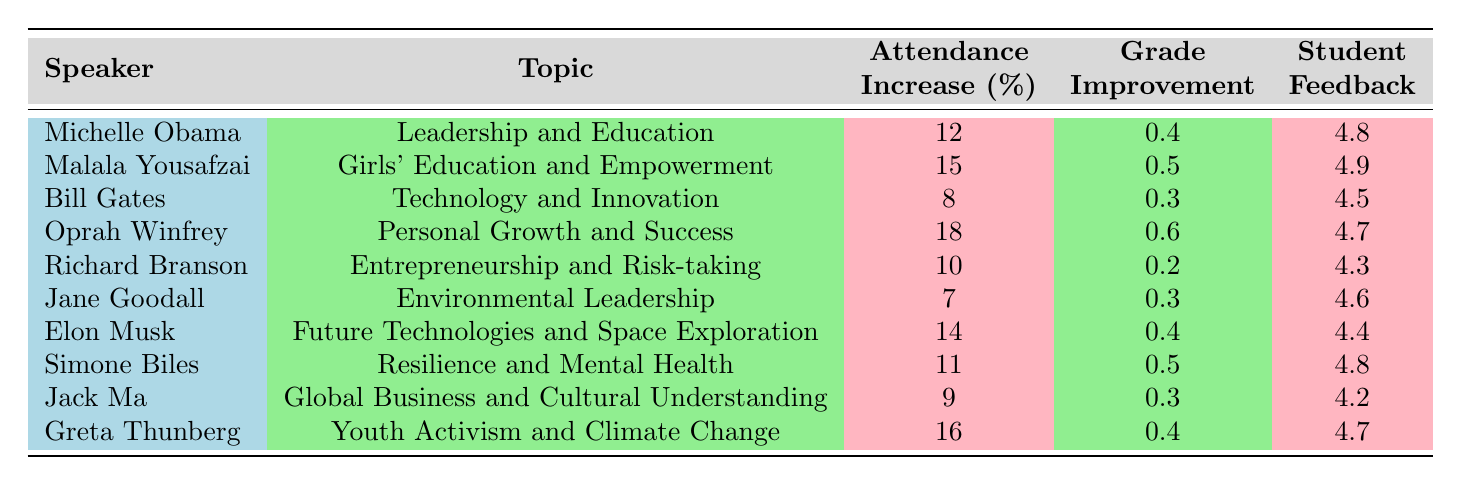What speaker achieved the highest attendance increase? By looking at the "Attendance Increase" column, Oprah Winfrey has the highest value of 18%.
Answer: Oprah Winfrey What is the attendance increase for Malala Yousafzai? The table shows that Malala Yousafzai has an attendance increase of 15%.
Answer: 15% Which speaker has the lowest grade improvement? The "Grade Improvement" column indicates that Richard Branson has the lowest value of 0.2.
Answer: Richard Branson What is the average student feedback score for all speakers? To find the average, we sum all feedback scores (4.8 + 4.9 + 4.5 + 4.7 + 4.3 + 4.6 + 4.4 + 4.8 + 4.2 + 4.7 = 46) and divide by the number of speakers (10). Average = 46 / 10 = 4.6.
Answer: 4.6 Did any speaker have an attendance increase of 12% or less? By checking the "Attendance Increase" column, only Bill Gates (8%) and Jane Goodall (7%) meet this condition.
Answer: Yes Which speaker had the highest grade improvement along with attendance increase? Oprah Winfrey has the highest attendance increase of 18% and a grade improvement of 0.6, which is also the highest.
Answer: Oprah Winfrey How many speakers had an attendance increase greater than or equal to 15%? By reviewing the "Attendance Increase" column, the speakers with increases of 15% or greater are Malala Yousafzai, Oprah Winfrey, Elon Musk, and Greta Thunberg, totaling 4 speakers.
Answer: 4 What is the difference between the highest and lowest student feedback scores? The highest feedback score is 4.9 (Malala Yousafzai) and the lowest is 4.2 (Jack Ma). The difference is 4.9 - 4.2 = 0.7.
Answer: 0.7 Is there any speaker whose feedback score is lower than 4.5? The speakers with feedback scores lower than 4.5 are Bill Gates (4.5) and Jack Ma (4.2). Thus, only Jack Ma qualifies here.
Answer: Yes 